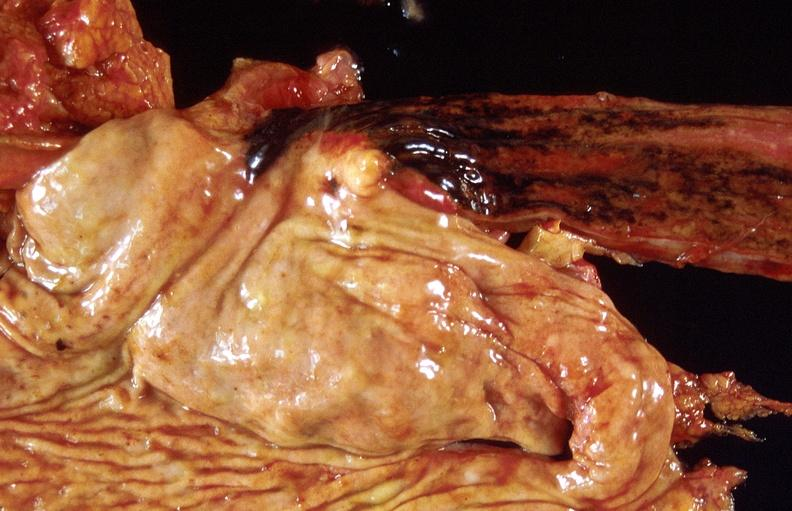what does this image show?
Answer the question using a single word or phrase. Stress ulcers 